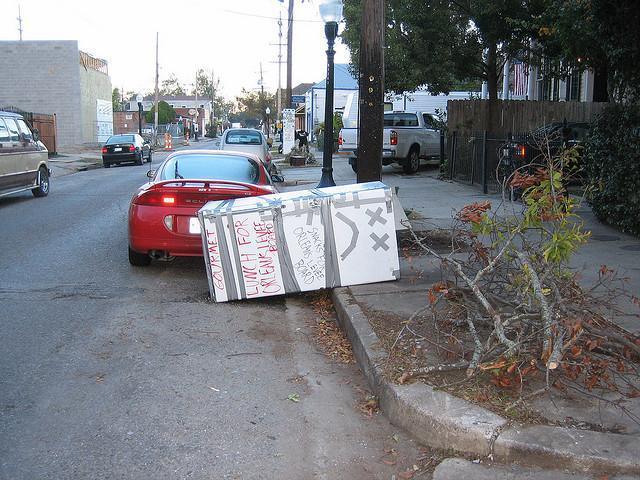How many cars are there?
Give a very brief answer. 2. 